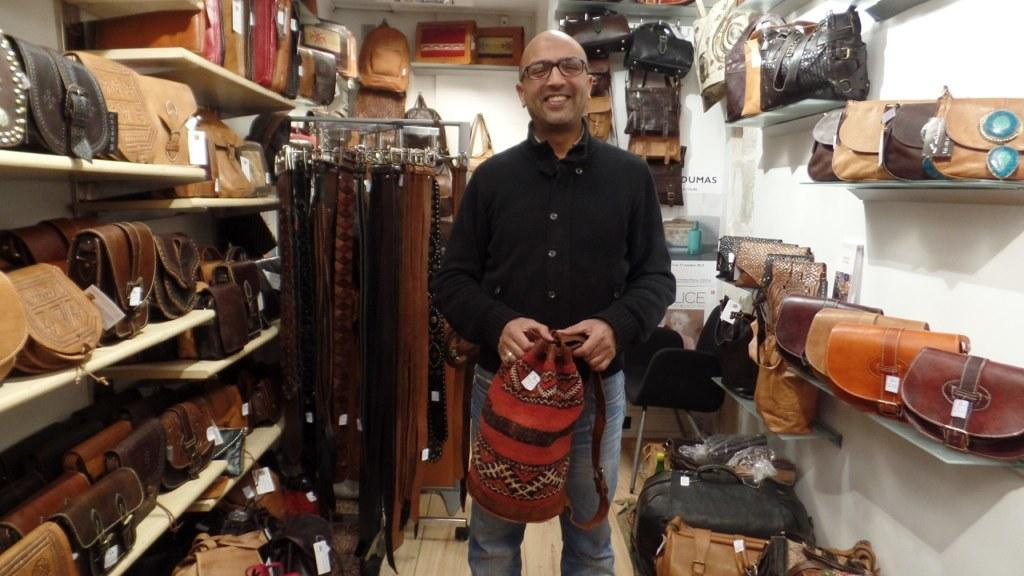Who is present in the image? There is a man in the image. What is the man doing in the image? The man is holding an object in his hands and smiling. What can be seen on the shelf in the image? There are bags on a shelf in the image. What is hanging in the image? There are clothes hanging in the image. What type of trouble is the man causing with the gun in the image? There is no gun present in the image, and the man is not causing any trouble. 